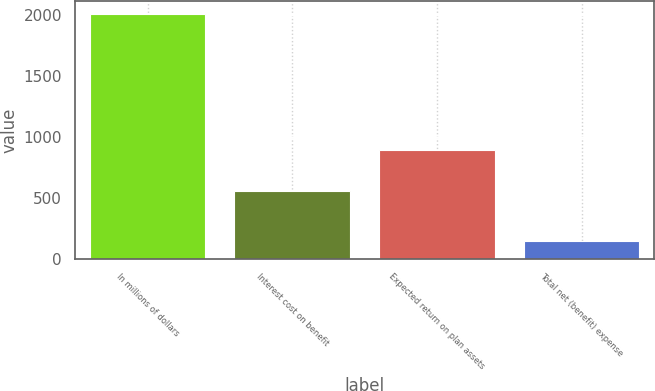Convert chart. <chart><loc_0><loc_0><loc_500><loc_500><bar_chart><fcel>In millions of dollars<fcel>Interest cost on benefit<fcel>Expected return on plan assets<fcel>Total net (benefit) expense<nl><fcel>2015<fcel>553<fcel>893<fcel>143<nl></chart> 